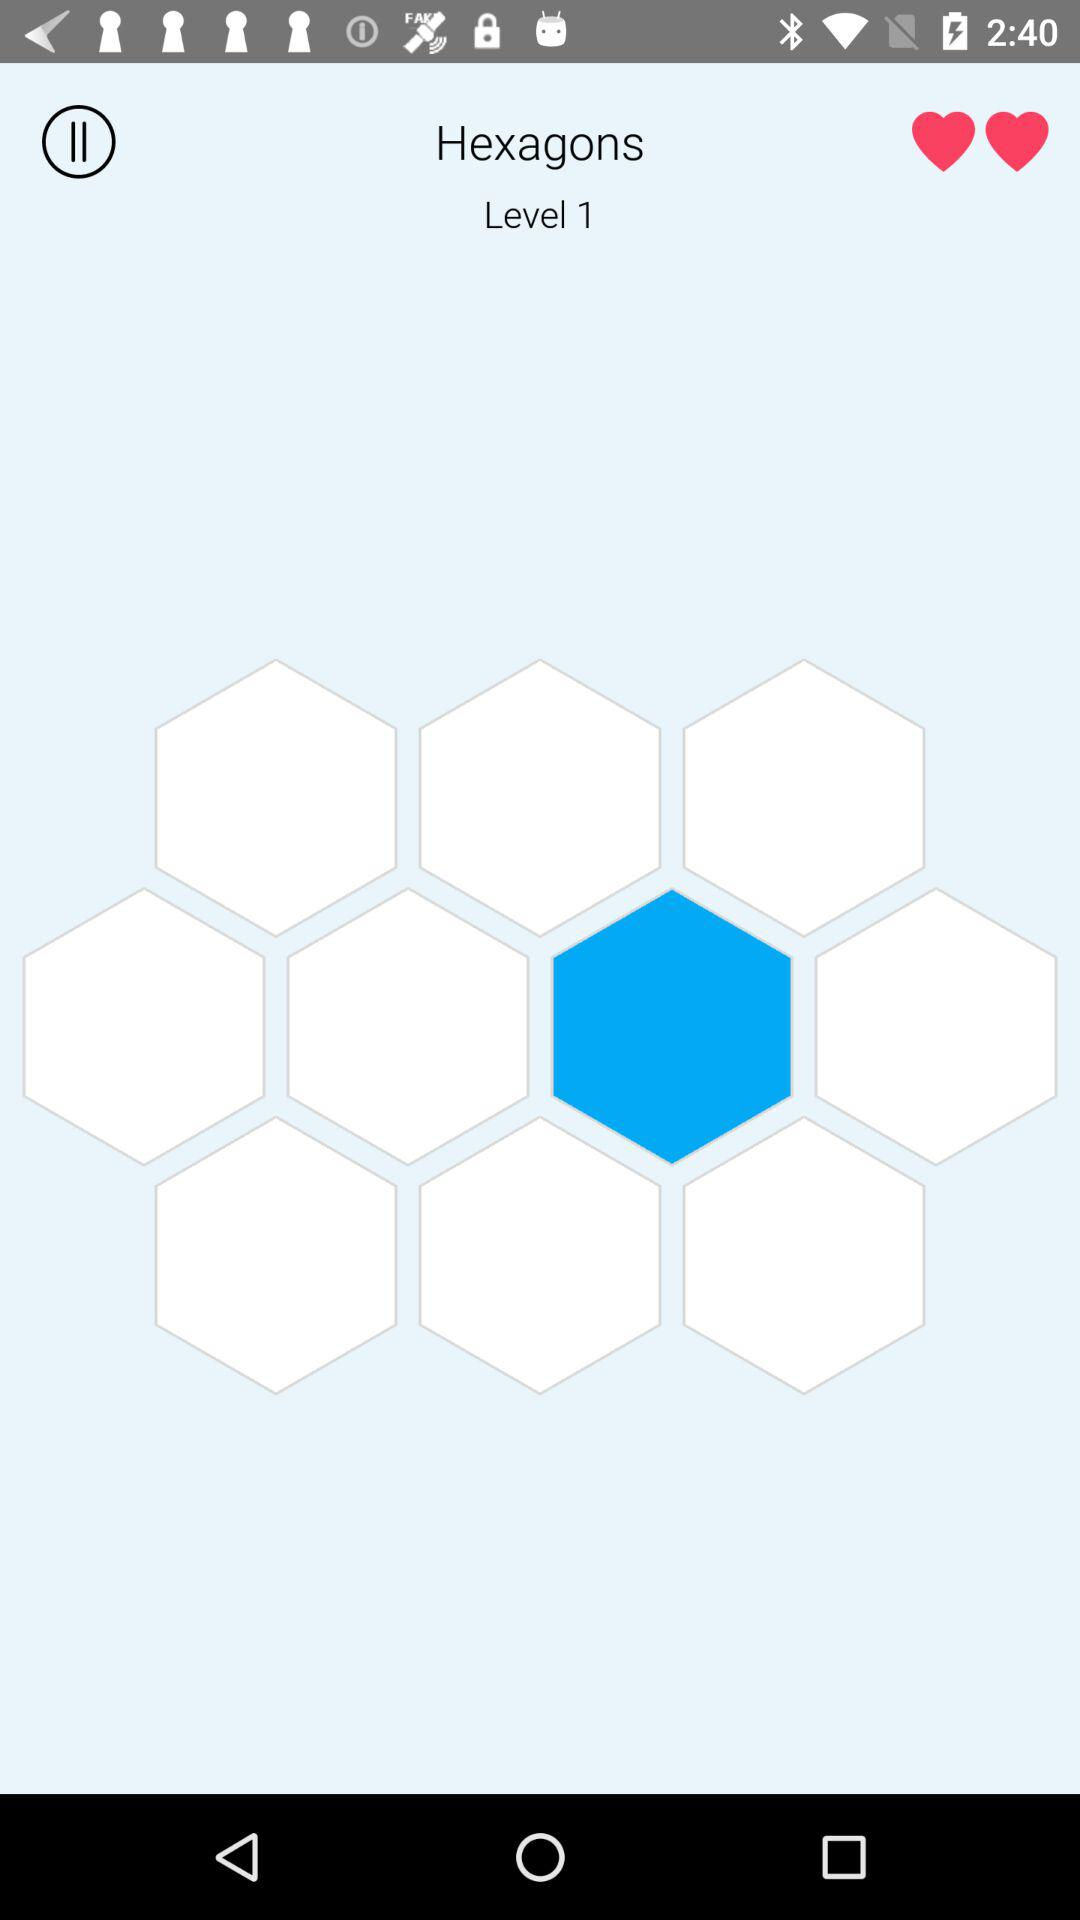How many hearts are on the screen?
Answer the question using a single word or phrase. 2 